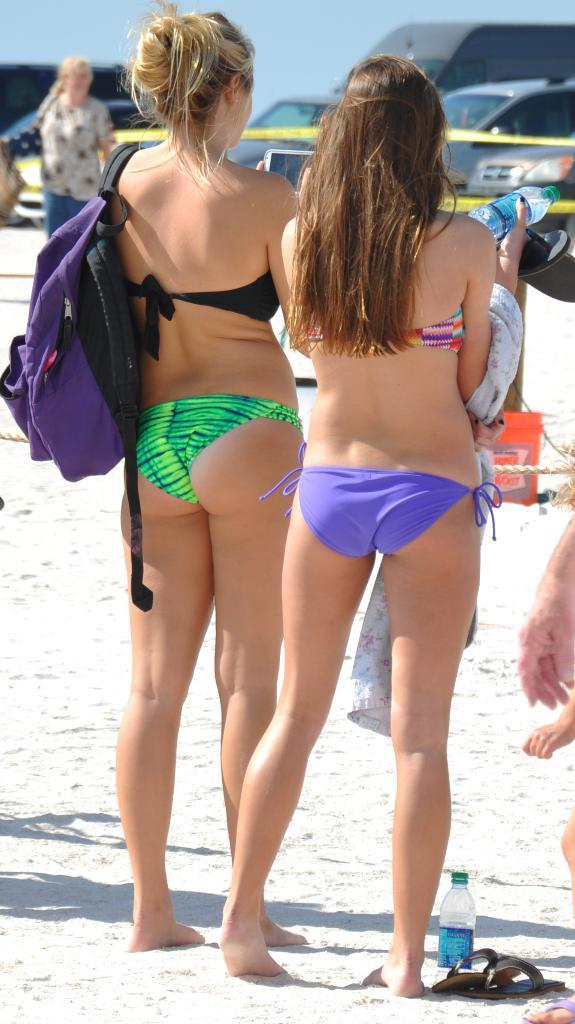How many people are in the image? There are two women standing in the image. What can be seen in the background of the image? There are cars in the background of the image. What is visible at the top of the image? The sky is visible at the top of the image. What type of digestive system does the jellyfish have in the image? There is no jellyfish present in the image, so it is not possible to determine its digestive system. 